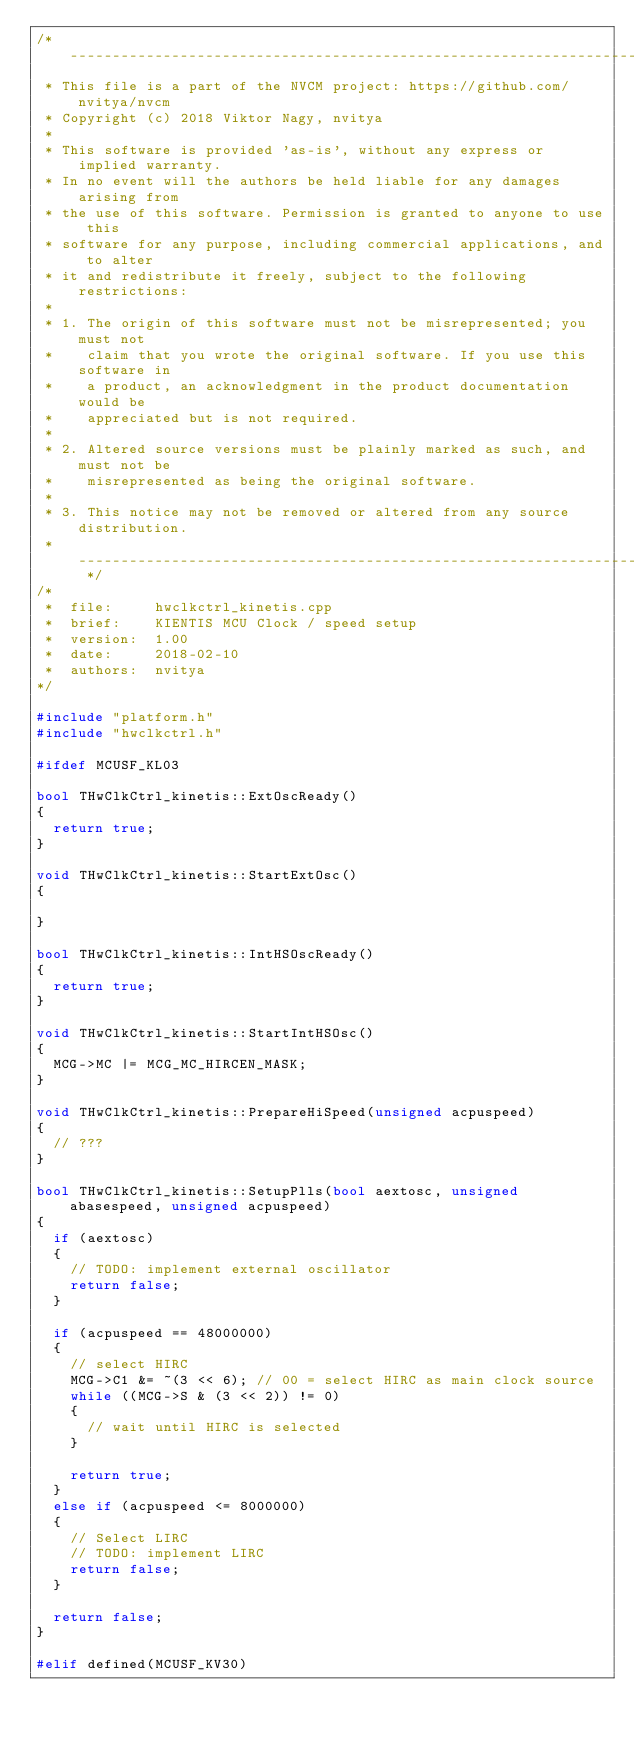<code> <loc_0><loc_0><loc_500><loc_500><_C++_>/* -----------------------------------------------------------------------------
 * This file is a part of the NVCM project: https://github.com/nvitya/nvcm
 * Copyright (c) 2018 Viktor Nagy, nvitya
 *
 * This software is provided 'as-is', without any express or implied warranty.
 * In no event will the authors be held liable for any damages arising from
 * the use of this software. Permission is granted to anyone to use this
 * software for any purpose, including commercial applications, and to alter
 * it and redistribute it freely, subject to the following restrictions:
 *
 * 1. The origin of this software must not be misrepresented; you must not
 *    claim that you wrote the original software. If you use this software in
 *    a product, an acknowledgment in the product documentation would be
 *    appreciated but is not required.
 *
 * 2. Altered source versions must be plainly marked as such, and must not be
 *    misrepresented as being the original software.
 *
 * 3. This notice may not be removed or altered from any source distribution.
 * --------------------------------------------------------------------------- */
/*
 *  file:     hwclkctrl_kinetis.cpp
 *  brief:    KIENTIS MCU Clock / speed setup
 *  version:  1.00
 *  date:     2018-02-10
 *  authors:  nvitya
*/

#include "platform.h"
#include "hwclkctrl.h"

#ifdef MCUSF_KL03

bool THwClkCtrl_kinetis::ExtOscReady()
{
  return true;
}

void THwClkCtrl_kinetis::StartExtOsc()
{

}

bool THwClkCtrl_kinetis::IntHSOscReady()
{
	return true;
}

void THwClkCtrl_kinetis::StartIntHSOsc()
{
	MCG->MC |= MCG_MC_HIRCEN_MASK;
}

void THwClkCtrl_kinetis::PrepareHiSpeed(unsigned acpuspeed)
{
	// ???
}

bool THwClkCtrl_kinetis::SetupPlls(bool aextosc, unsigned abasespeed, unsigned acpuspeed)
{
	if (aextosc)
	{
		// TODO: implement external oscillator
		return false;
	}

	if (acpuspeed == 48000000)
	{
		// select HIRC
		MCG->C1 &= ~(3 << 6); // 00 = select HIRC as main clock source
		while ((MCG->S & (3 << 2)) != 0)
		{
			// wait until HIRC is selected
		}

		return true;
	}
	else if (acpuspeed <= 8000000)
	{
		// Select LIRC
		// TODO: implement LIRC
		return false;
	}

  return false;
}

#elif defined(MCUSF_KV30)
</code> 